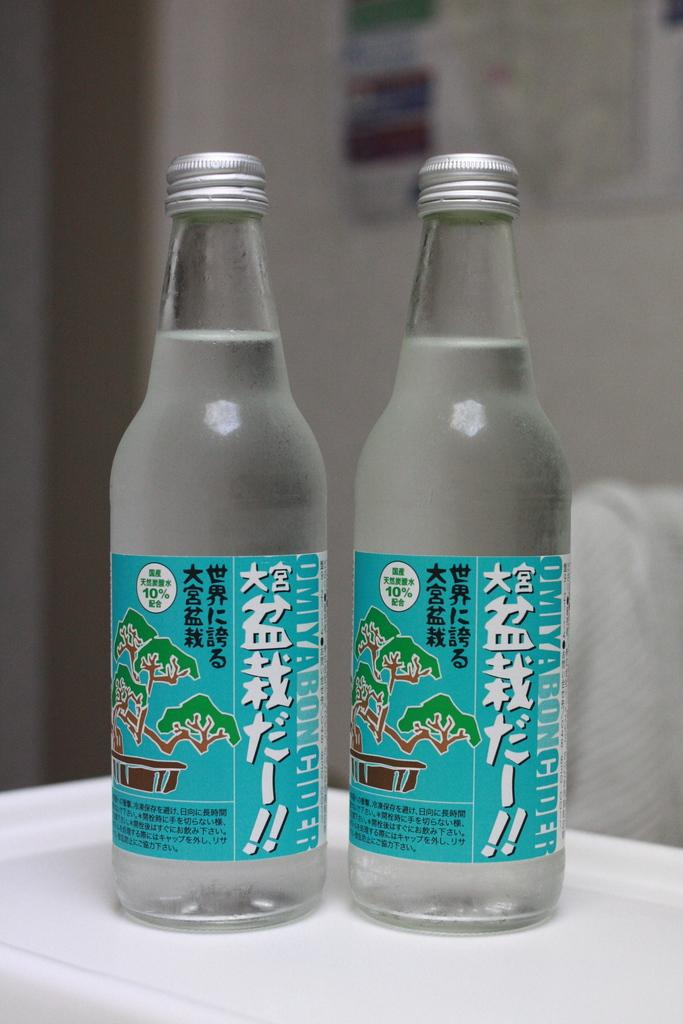<image>
Offer a succinct explanation of the picture presented. Two unopened bottles of Omiyaboncider containing 10% alcohol 